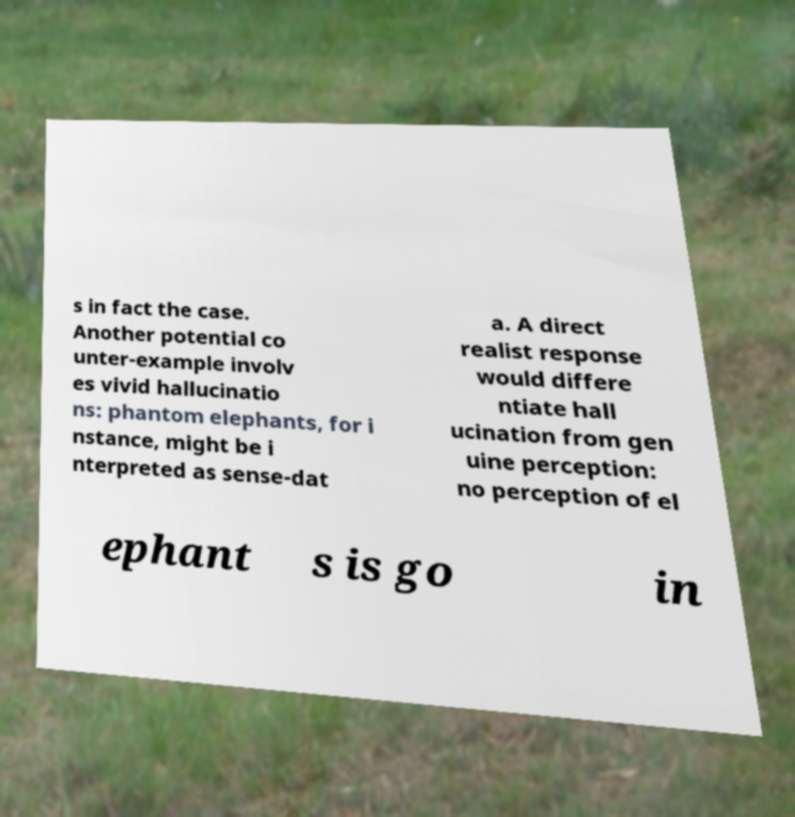For documentation purposes, I need the text within this image transcribed. Could you provide that? s in fact the case. Another potential co unter-example involv es vivid hallucinatio ns: phantom elephants, for i nstance, might be i nterpreted as sense-dat a. A direct realist response would differe ntiate hall ucination from gen uine perception: no perception of el ephant s is go in 